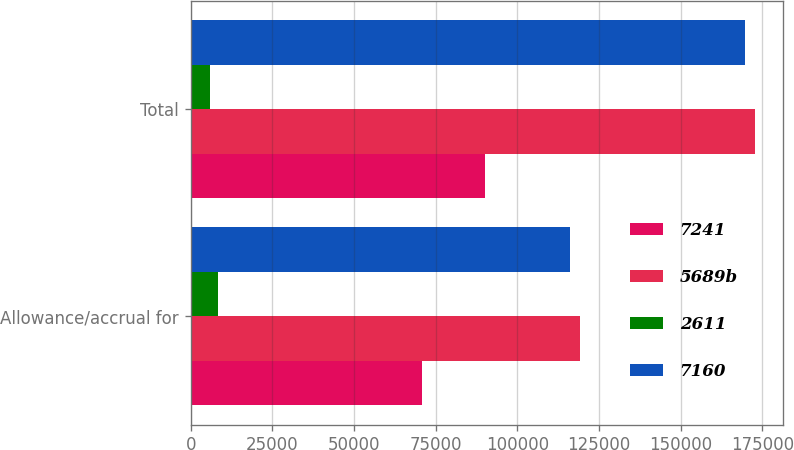Convert chart to OTSL. <chart><loc_0><loc_0><loc_500><loc_500><stacked_bar_chart><ecel><fcel>Allowance/accrual for<fcel>Total<nl><fcel>7241<fcel>70945<fcel>90212<nl><fcel>5689b<fcel>119267<fcel>172615<nl><fcel>2611<fcel>8233<fcel>5745<nl><fcel>7160<fcel>116200<fcel>169712<nl></chart> 